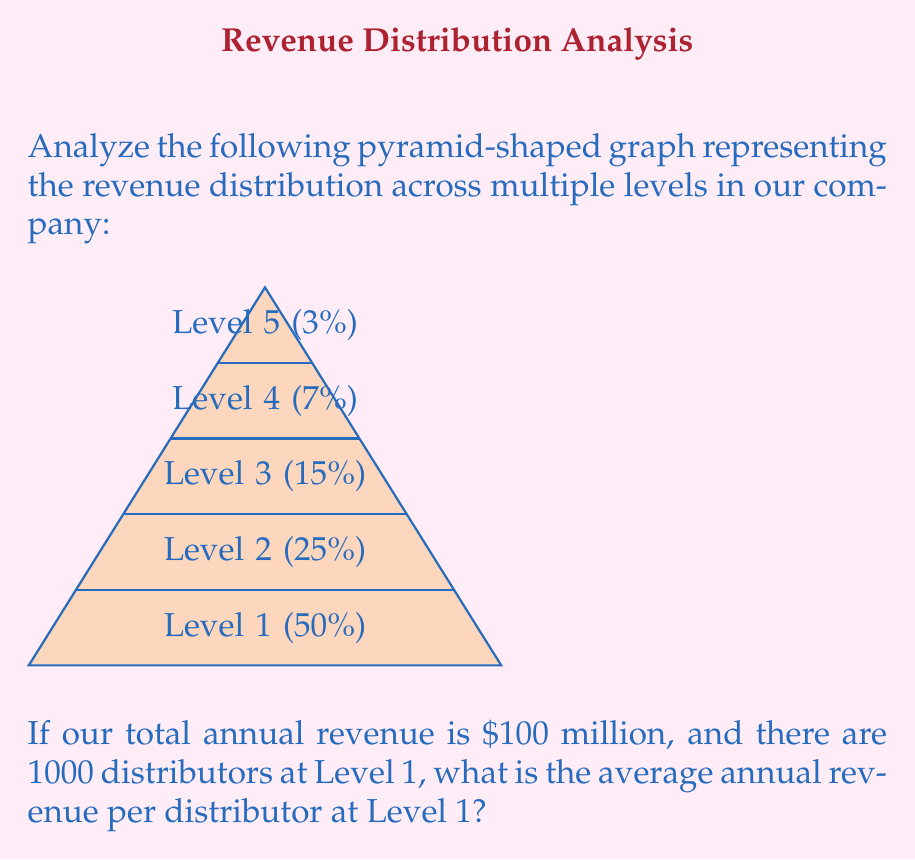Can you solve this math problem? To solve this problem, we'll follow these steps:

1. Identify the percentage of revenue for Level 1:
   From the pyramid graph, we can see that Level 1 receives 50% of the total revenue.

2. Calculate the total revenue for Level 1:
   Total annual revenue = $100 million
   Level 1 percentage = 50% = 0.50
   Level 1 revenue = $100 million × 0.50 = $50 million

3. Calculate the average revenue per distributor at Level 1:
   Number of distributors at Level 1 = 1000
   Average revenue per distributor = Total Level 1 revenue ÷ Number of distributors
   
   $$ \text{Average revenue per distributor} = \frac{\$50,000,000}{1000} = \$50,000 $$

Therefore, the average annual revenue per distributor at Level 1 is $50,000.
Answer: $50,000 